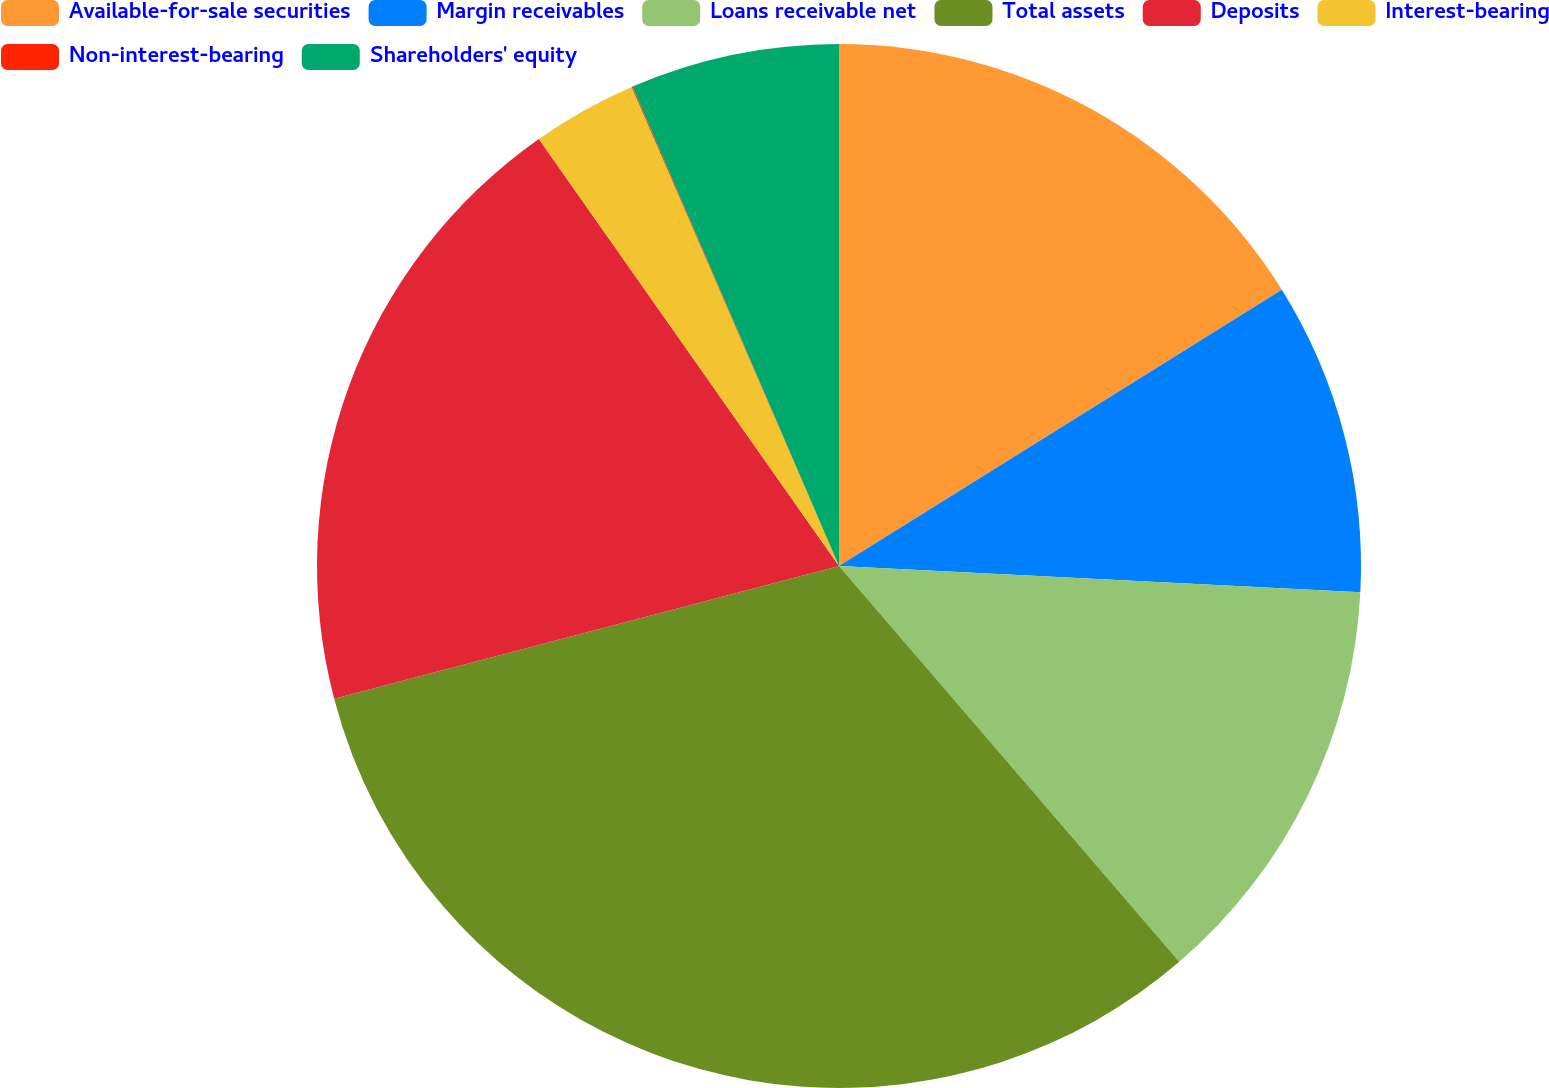<chart> <loc_0><loc_0><loc_500><loc_500><pie_chart><fcel>Available-for-sale securities<fcel>Margin receivables<fcel>Loans receivable net<fcel>Total assets<fcel>Deposits<fcel>Interest-bearing<fcel>Non-interest-bearing<fcel>Shareholders' equity<nl><fcel>16.12%<fcel>9.68%<fcel>12.9%<fcel>32.21%<fcel>19.34%<fcel>3.25%<fcel>0.03%<fcel>6.47%<nl></chart> 